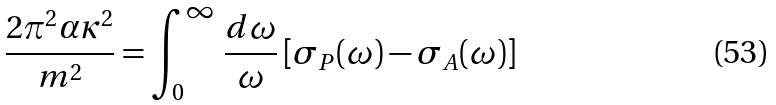<formula> <loc_0><loc_0><loc_500><loc_500>\frac { 2 \pi ^ { 2 } \alpha \kappa ^ { 2 } } { m ^ { 2 } } = \int ^ { \infty } _ { 0 } \, \frac { d \omega } { \omega } \, [ \sigma _ { P } ( \omega ) - \sigma _ { A } ( \omega ) ]</formula> 